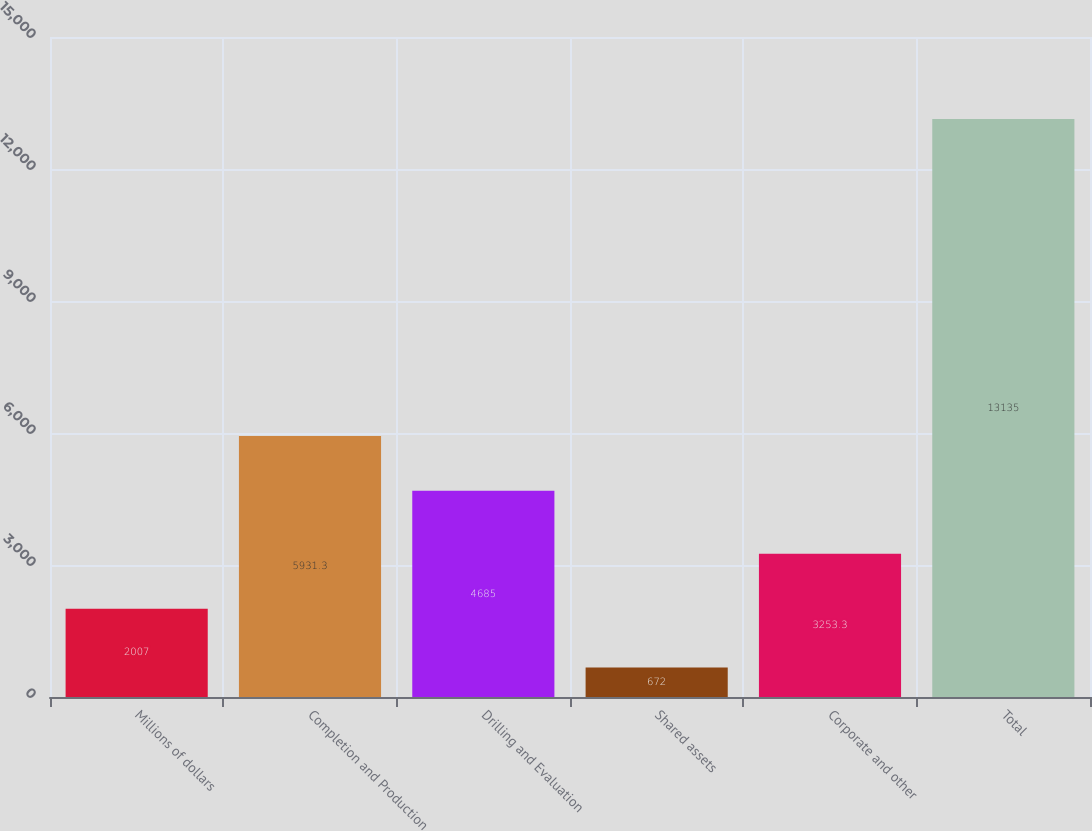Convert chart to OTSL. <chart><loc_0><loc_0><loc_500><loc_500><bar_chart><fcel>Millions of dollars<fcel>Completion and Production<fcel>Drilling and Evaluation<fcel>Shared assets<fcel>Corporate and other<fcel>Total<nl><fcel>2007<fcel>5931.3<fcel>4685<fcel>672<fcel>3253.3<fcel>13135<nl></chart> 